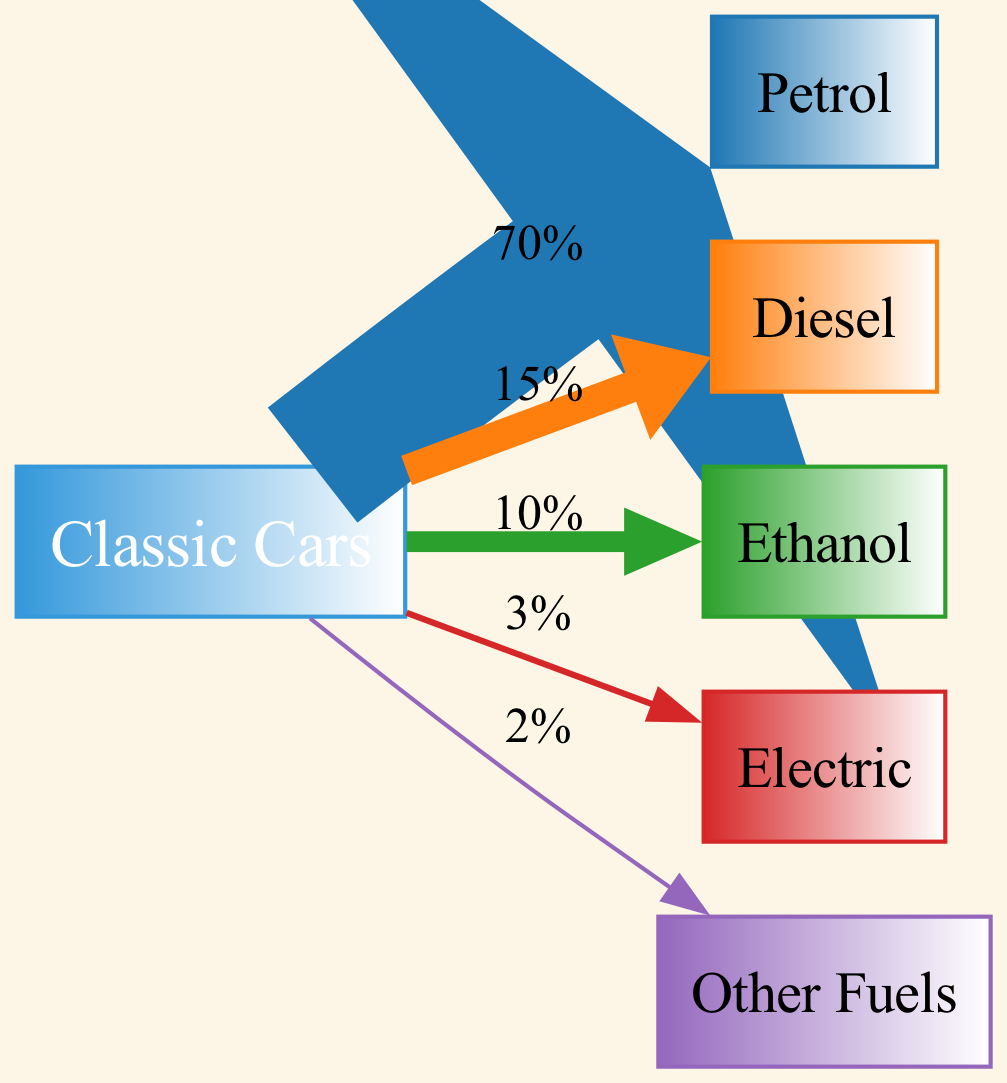What is the most used fuel type for classic cars? The diagram shows that petrol has the highest value going from the source "Classic Cars" to the node "Petrol," which indicates it is the most used fuel type. The link's value is 70.
Answer: Petrol What percentage of classic cars use diesel as their fuel? By examining the link from "Classic Cars" to "Diesel," we see that its value is 15, indicating that 15% of classic cars use diesel for fuel.
Answer: 15% How many fuel types are represented in the diagram? The diagram includes five fuel types represented as individual nodes: Petrol, Diesel, Ethanol, Electric, and Other Fuels. Counting these gives us five fuel types.
Answer: Five Which fuel type has the least usage in classic cars? Looking at the links, "Other Fuels" has the lowest value of 2, indicating that it is the least used fuel type among classic cars.
Answer: Other Fuels What is the total percentage of classic cars that use alternative fuels (Ethanol, Electric, Other Fuels)? To answer this, we sum the values of Ethanol (10), Electric (3), and Other Fuels (2). This results in 15% for alternative fuels (10 + 3 + 2 = 15).
Answer: 15% What is the cumulative percentage of classic cars using petrol and diesel combined? By adding the percentages of petrol (70) and diesel (15), we find that the cumulative percentage is 85% (70 + 15 = 85).
Answer: 85% What type of fuel is found at the furthest right in the diagram? The furthest right node in the flow of the diagram is "Other Fuels," which is the last fuel type listed after Electric.
Answer: Other Fuels What relationship can be inferred between classic cars and electric fuel usage? The diagram shows that 3% of classic cars use Electric fuel, with a link from "Classic Cars" to "Electric" indicating that there is a connection, albeit a smaller one, between classic cars and electric fuel usage.
Answer: 3% 